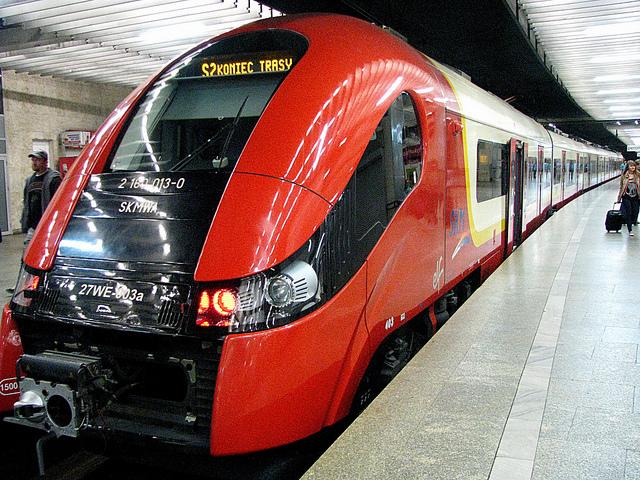Where can I catch this from?
Concise answer only. Koniec trasy. Is there anyone waiting for the train?
Concise answer only. Yes. Is the train red and black?
Keep it brief. Yes. 